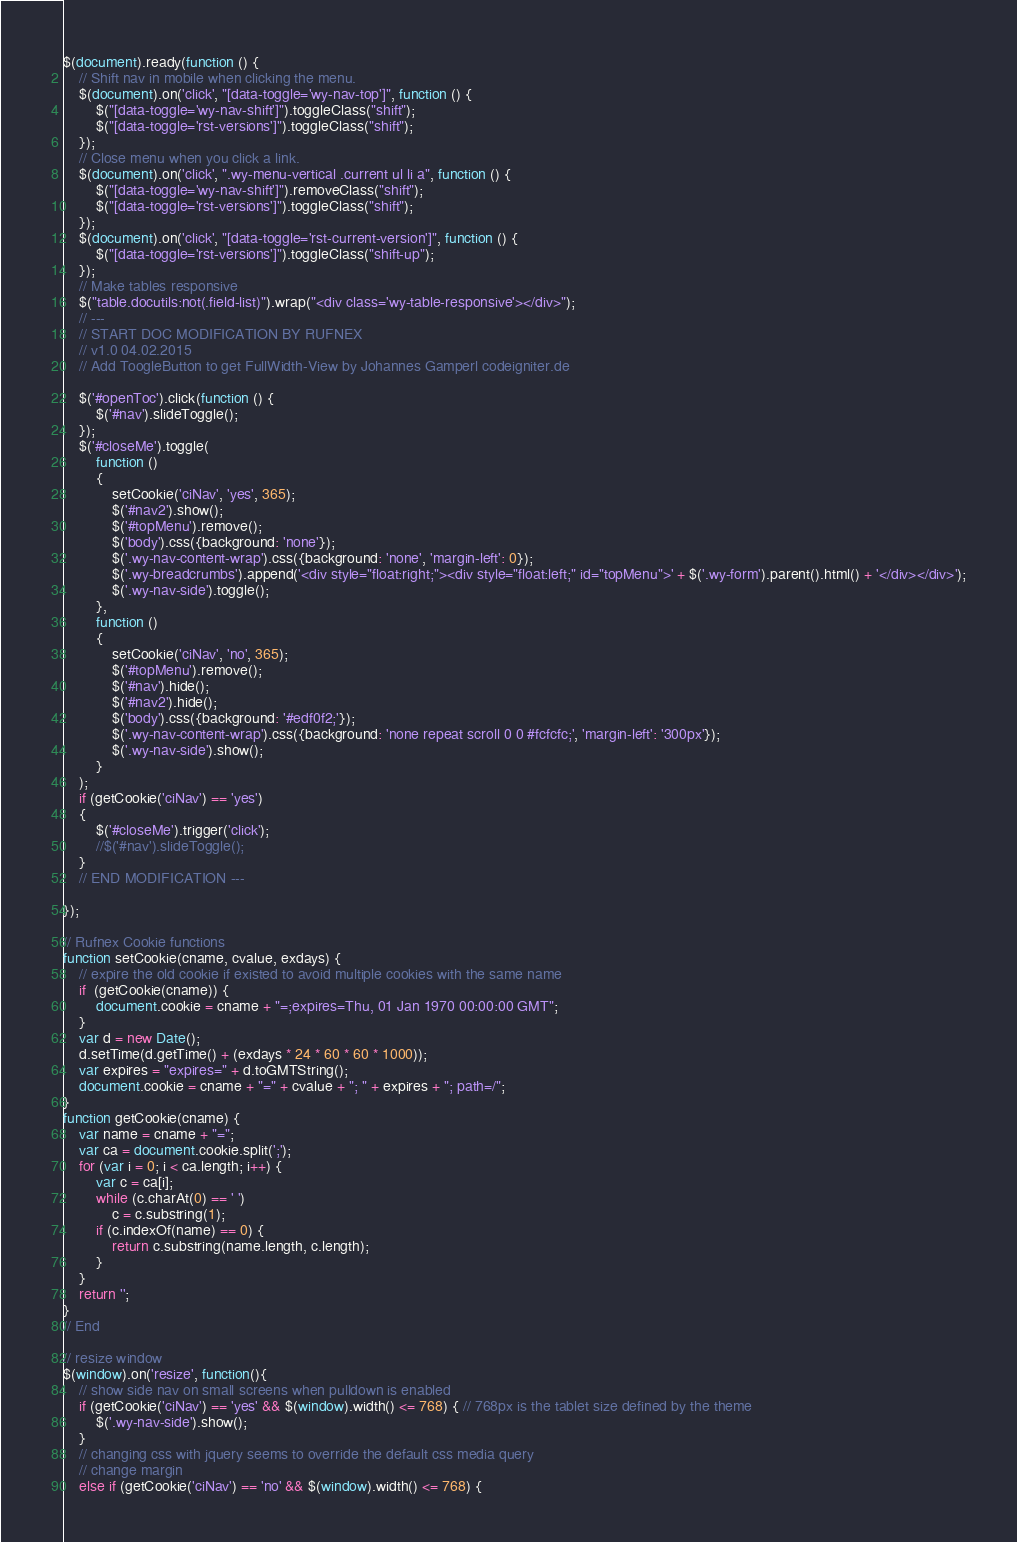<code> <loc_0><loc_0><loc_500><loc_500><_JavaScript_>$(document).ready(function () {
    // Shift nav in mobile when clicking the menu.
    $(document).on('click', "[data-toggle='wy-nav-top']", function () {
        $("[data-toggle='wy-nav-shift']").toggleClass("shift");
        $("[data-toggle='rst-versions']").toggleClass("shift");
    });
    // Close menu when you click a link.
    $(document).on('click', ".wy-menu-vertical .current ul li a", function () {
        $("[data-toggle='wy-nav-shift']").removeClass("shift");
        $("[data-toggle='rst-versions']").toggleClass("shift");
    });
    $(document).on('click', "[data-toggle='rst-current-version']", function () {
        $("[data-toggle='rst-versions']").toggleClass("shift-up");
    });
    // Make tables responsive
    $("table.docutils:not(.field-list)").wrap("<div class='wy-table-responsive'></div>");
    // ---
    // START DOC MODIFICATION BY RUFNEX
    // v1.0 04.02.2015
    // Add ToogleButton to get FullWidth-View by Johannes Gamperl codeigniter.de

    $('#openToc').click(function () {
        $('#nav').slideToggle();
    });
    $('#closeMe').toggle(
        function ()
        {
            setCookie('ciNav', 'yes', 365);
            $('#nav2').show();
            $('#topMenu').remove();
            $('body').css({background: 'none'});
            $('.wy-nav-content-wrap').css({background: 'none', 'margin-left': 0});
            $('.wy-breadcrumbs').append('<div style="float:right;"><div style="float:left;" id="topMenu">' + $('.wy-form').parent().html() + '</div></div>');
            $('.wy-nav-side').toggle();
        },
        function ()
        {
            setCookie('ciNav', 'no', 365);
            $('#topMenu').remove();
            $('#nav').hide();
            $('#nav2').hide();
            $('body').css({background: '#edf0f2;'});
            $('.wy-nav-content-wrap').css({background: 'none repeat scroll 0 0 #fcfcfc;', 'margin-left': '300px'});
            $('.wy-nav-side').show();
        }
    );
    if (getCookie('ciNav') == 'yes')
    {
        $('#closeMe').trigger('click');
        //$('#nav').slideToggle();
    }
    // END MODIFICATION ---

});

// Rufnex Cookie functions
function setCookie(cname, cvalue, exdays) {
    // expire the old cookie if existed to avoid multiple cookies with the same name
    if  (getCookie(cname)) {
        document.cookie = cname + "=;expires=Thu, 01 Jan 1970 00:00:00 GMT";
    }
    var d = new Date();
    d.setTime(d.getTime() + (exdays * 24 * 60 * 60 * 1000));
    var expires = "expires=" + d.toGMTString();
    document.cookie = cname + "=" + cvalue + "; " + expires + "; path=/";
}
function getCookie(cname) {
    var name = cname + "=";
    var ca = document.cookie.split(';');
    for (var i = 0; i < ca.length; i++) {
        var c = ca[i];
        while (c.charAt(0) == ' ')
            c = c.substring(1);
        if (c.indexOf(name) == 0) {
            return c.substring(name.length, c.length);
        }
    }
    return '';
}
// End

// resize window
$(window).on('resize', function(){
    // show side nav on small screens when pulldown is enabled
    if (getCookie('ciNav') == 'yes' && $(window).width() <= 768) { // 768px is the tablet size defined by the theme
        $('.wy-nav-side').show();
    }
    // changing css with jquery seems to override the default css media query
    // change margin
    else if (getCookie('ciNav') == 'no' && $(window).width() <= 768) {</code> 